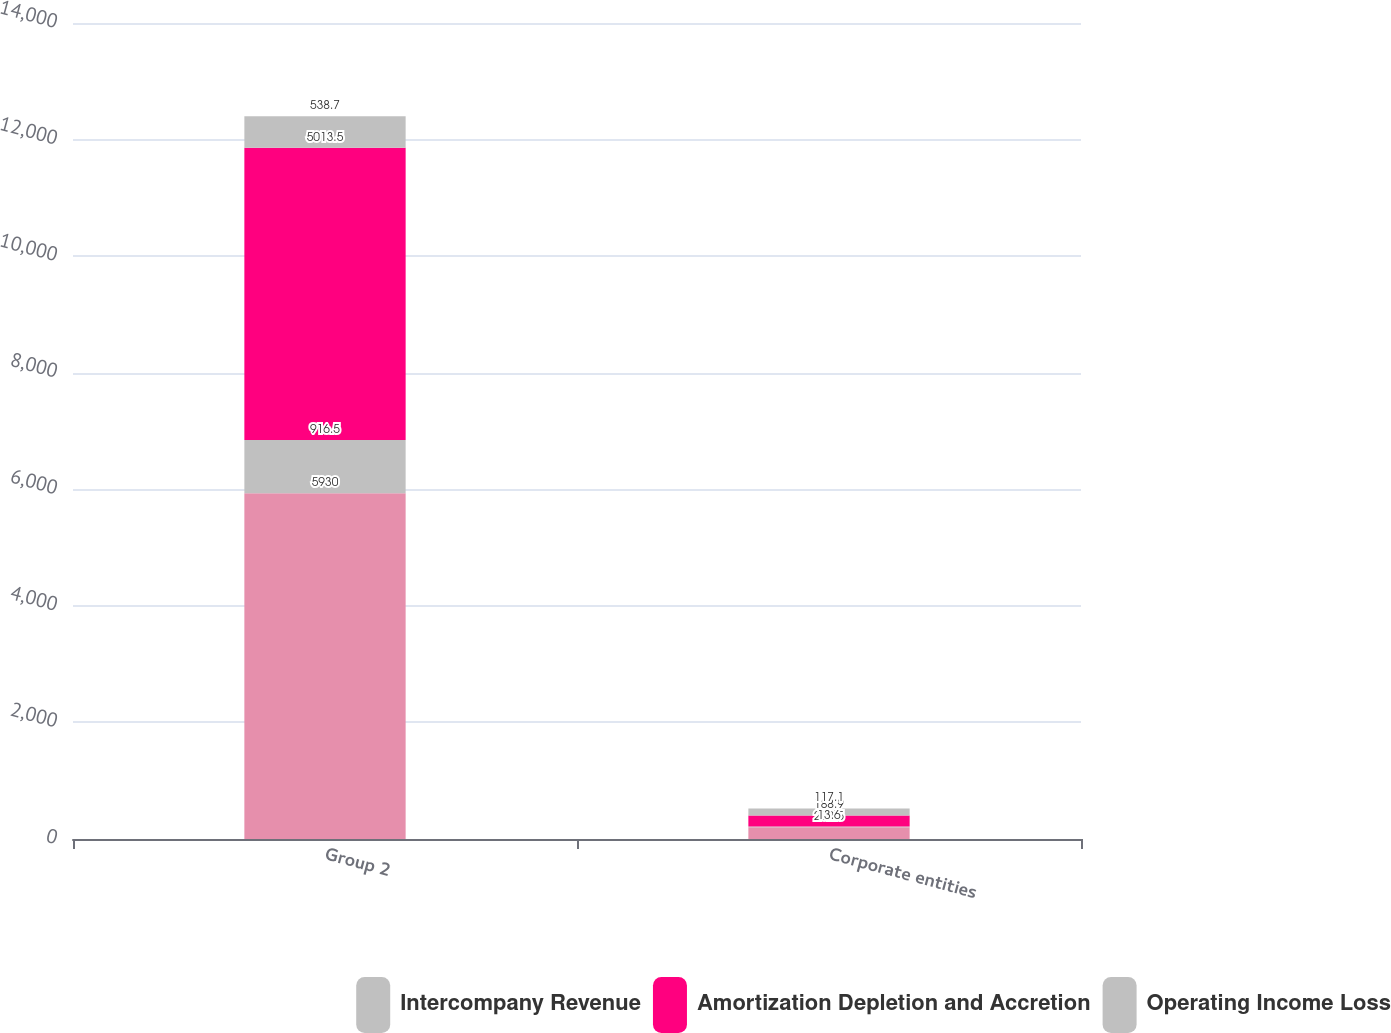Convert chart. <chart><loc_0><loc_0><loc_500><loc_500><stacked_bar_chart><ecel><fcel>Group 2<fcel>Corporate entities<nl><fcel>nan<fcel>5930<fcel>202.5<nl><fcel>Intercompany Revenue<fcel>916.5<fcel>13.6<nl><fcel>Amortization Depletion and Accretion<fcel>5013.5<fcel>188.9<nl><fcel>Operating Income Loss<fcel>538.7<fcel>117.1<nl></chart> 